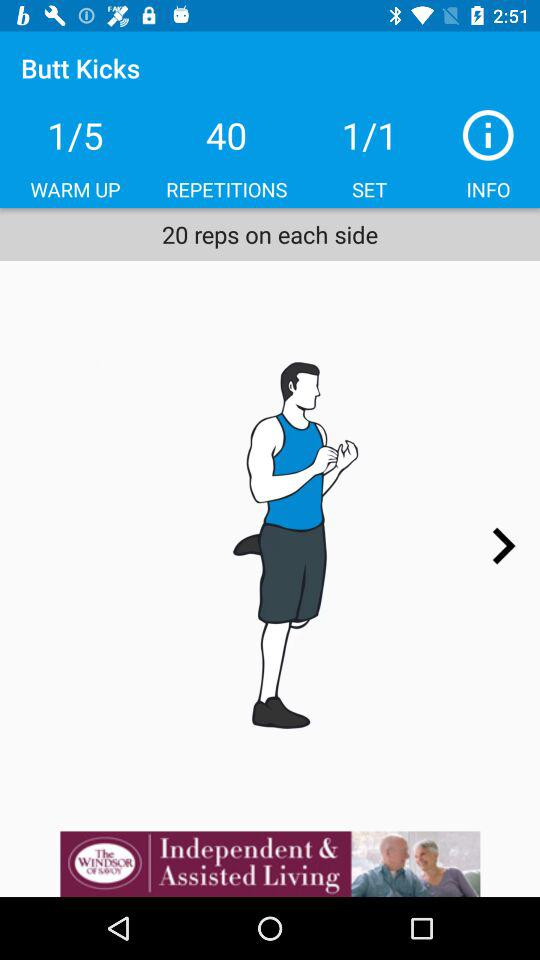What is the total number of exercises in the warm up? There are a total of 5 exercises. 